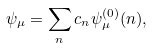Convert formula to latex. <formula><loc_0><loc_0><loc_500><loc_500>\psi _ { \mu } = \sum _ { n } c _ { n } \psi _ { \mu } ^ { ( 0 ) } ( n ) ,</formula> 